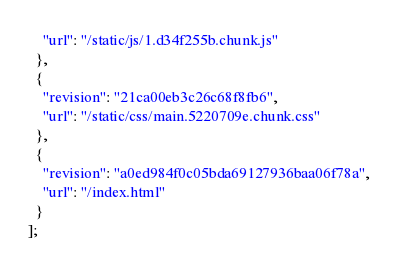Convert code to text. <code><loc_0><loc_0><loc_500><loc_500><_JavaScript_>    "url": "/static/js/1.d34f255b.chunk.js"
  },
  {
    "revision": "21ca00eb3c26c68f8fb6",
    "url": "/static/css/main.5220709e.chunk.css"
  },
  {
    "revision": "a0ed984f0c05bda69127936baa06f78a",
    "url": "/index.html"
  }
];</code> 